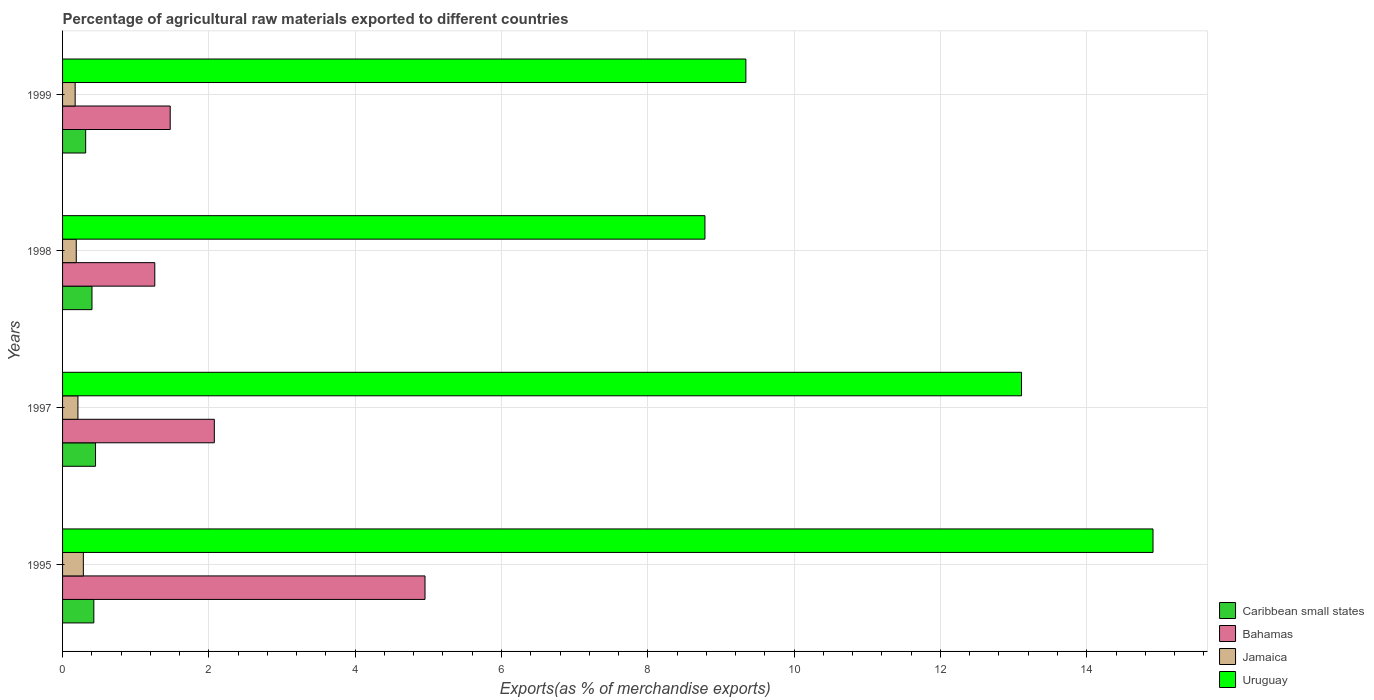How many groups of bars are there?
Give a very brief answer. 4. What is the label of the 2nd group of bars from the top?
Provide a succinct answer. 1998. What is the percentage of exports to different countries in Bahamas in 1999?
Your answer should be compact. 1.47. Across all years, what is the maximum percentage of exports to different countries in Jamaica?
Your answer should be very brief. 0.28. Across all years, what is the minimum percentage of exports to different countries in Uruguay?
Give a very brief answer. 8.78. In which year was the percentage of exports to different countries in Bahamas minimum?
Your response must be concise. 1998. What is the total percentage of exports to different countries in Bahamas in the graph?
Offer a terse response. 9.76. What is the difference between the percentage of exports to different countries in Jamaica in 1995 and that in 1997?
Your answer should be compact. 0.07. What is the difference between the percentage of exports to different countries in Caribbean small states in 1997 and the percentage of exports to different countries in Bahamas in 1998?
Your answer should be compact. -0.81. What is the average percentage of exports to different countries in Bahamas per year?
Offer a terse response. 2.44. In the year 1997, what is the difference between the percentage of exports to different countries in Uruguay and percentage of exports to different countries in Caribbean small states?
Your response must be concise. 12.66. In how many years, is the percentage of exports to different countries in Jamaica greater than 11.2 %?
Give a very brief answer. 0. What is the ratio of the percentage of exports to different countries in Bahamas in 1995 to that in 1998?
Ensure brevity in your answer.  3.93. Is the percentage of exports to different countries in Uruguay in 1997 less than that in 1998?
Give a very brief answer. No. What is the difference between the highest and the second highest percentage of exports to different countries in Caribbean small states?
Provide a short and direct response. 0.02. What is the difference between the highest and the lowest percentage of exports to different countries in Jamaica?
Provide a short and direct response. 0.11. Is it the case that in every year, the sum of the percentage of exports to different countries in Caribbean small states and percentage of exports to different countries in Uruguay is greater than the sum of percentage of exports to different countries in Jamaica and percentage of exports to different countries in Bahamas?
Give a very brief answer. Yes. What does the 3rd bar from the top in 1998 represents?
Your answer should be compact. Bahamas. What does the 3rd bar from the bottom in 1998 represents?
Offer a very short reply. Jamaica. Is it the case that in every year, the sum of the percentage of exports to different countries in Jamaica and percentage of exports to different countries in Uruguay is greater than the percentage of exports to different countries in Bahamas?
Provide a succinct answer. Yes. Are all the bars in the graph horizontal?
Your answer should be very brief. Yes. Are the values on the major ticks of X-axis written in scientific E-notation?
Provide a succinct answer. No. Does the graph contain any zero values?
Provide a succinct answer. No. Does the graph contain grids?
Keep it short and to the point. Yes. Where does the legend appear in the graph?
Ensure brevity in your answer.  Bottom right. How many legend labels are there?
Provide a succinct answer. 4. What is the title of the graph?
Give a very brief answer. Percentage of agricultural raw materials exported to different countries. What is the label or title of the X-axis?
Offer a terse response. Exports(as % of merchandise exports). What is the Exports(as % of merchandise exports) in Caribbean small states in 1995?
Offer a terse response. 0.43. What is the Exports(as % of merchandise exports) in Bahamas in 1995?
Your answer should be compact. 4.95. What is the Exports(as % of merchandise exports) of Jamaica in 1995?
Your answer should be compact. 0.28. What is the Exports(as % of merchandise exports) of Uruguay in 1995?
Your answer should be compact. 14.91. What is the Exports(as % of merchandise exports) in Caribbean small states in 1997?
Make the answer very short. 0.45. What is the Exports(as % of merchandise exports) of Bahamas in 1997?
Make the answer very short. 2.07. What is the Exports(as % of merchandise exports) of Jamaica in 1997?
Your answer should be compact. 0.21. What is the Exports(as % of merchandise exports) of Uruguay in 1997?
Provide a succinct answer. 13.11. What is the Exports(as % of merchandise exports) in Caribbean small states in 1998?
Your answer should be very brief. 0.4. What is the Exports(as % of merchandise exports) of Bahamas in 1998?
Your answer should be very brief. 1.26. What is the Exports(as % of merchandise exports) in Jamaica in 1998?
Offer a very short reply. 0.19. What is the Exports(as % of merchandise exports) of Uruguay in 1998?
Offer a very short reply. 8.78. What is the Exports(as % of merchandise exports) in Caribbean small states in 1999?
Provide a succinct answer. 0.32. What is the Exports(as % of merchandise exports) of Bahamas in 1999?
Offer a terse response. 1.47. What is the Exports(as % of merchandise exports) of Jamaica in 1999?
Ensure brevity in your answer.  0.17. What is the Exports(as % of merchandise exports) in Uruguay in 1999?
Your answer should be very brief. 9.34. Across all years, what is the maximum Exports(as % of merchandise exports) of Caribbean small states?
Ensure brevity in your answer.  0.45. Across all years, what is the maximum Exports(as % of merchandise exports) in Bahamas?
Make the answer very short. 4.95. Across all years, what is the maximum Exports(as % of merchandise exports) of Jamaica?
Make the answer very short. 0.28. Across all years, what is the maximum Exports(as % of merchandise exports) in Uruguay?
Make the answer very short. 14.91. Across all years, what is the minimum Exports(as % of merchandise exports) in Caribbean small states?
Provide a short and direct response. 0.32. Across all years, what is the minimum Exports(as % of merchandise exports) in Bahamas?
Offer a very short reply. 1.26. Across all years, what is the minimum Exports(as % of merchandise exports) in Jamaica?
Provide a short and direct response. 0.17. Across all years, what is the minimum Exports(as % of merchandise exports) in Uruguay?
Your response must be concise. 8.78. What is the total Exports(as % of merchandise exports) in Caribbean small states in the graph?
Give a very brief answer. 1.6. What is the total Exports(as % of merchandise exports) in Bahamas in the graph?
Your answer should be compact. 9.76. What is the total Exports(as % of merchandise exports) of Jamaica in the graph?
Provide a short and direct response. 0.85. What is the total Exports(as % of merchandise exports) in Uruguay in the graph?
Provide a succinct answer. 46.13. What is the difference between the Exports(as % of merchandise exports) of Caribbean small states in 1995 and that in 1997?
Your answer should be compact. -0.02. What is the difference between the Exports(as % of merchandise exports) in Bahamas in 1995 and that in 1997?
Keep it short and to the point. 2.88. What is the difference between the Exports(as % of merchandise exports) in Jamaica in 1995 and that in 1997?
Give a very brief answer. 0.07. What is the difference between the Exports(as % of merchandise exports) in Uruguay in 1995 and that in 1997?
Ensure brevity in your answer.  1.8. What is the difference between the Exports(as % of merchandise exports) in Caribbean small states in 1995 and that in 1998?
Ensure brevity in your answer.  0.03. What is the difference between the Exports(as % of merchandise exports) of Bahamas in 1995 and that in 1998?
Offer a very short reply. 3.69. What is the difference between the Exports(as % of merchandise exports) of Jamaica in 1995 and that in 1998?
Provide a succinct answer. 0.1. What is the difference between the Exports(as % of merchandise exports) of Uruguay in 1995 and that in 1998?
Offer a terse response. 6.12. What is the difference between the Exports(as % of merchandise exports) of Caribbean small states in 1995 and that in 1999?
Give a very brief answer. 0.11. What is the difference between the Exports(as % of merchandise exports) of Bahamas in 1995 and that in 1999?
Keep it short and to the point. 3.48. What is the difference between the Exports(as % of merchandise exports) of Jamaica in 1995 and that in 1999?
Give a very brief answer. 0.11. What is the difference between the Exports(as % of merchandise exports) of Uruguay in 1995 and that in 1999?
Your answer should be compact. 5.57. What is the difference between the Exports(as % of merchandise exports) in Caribbean small states in 1997 and that in 1998?
Ensure brevity in your answer.  0.05. What is the difference between the Exports(as % of merchandise exports) in Bahamas in 1997 and that in 1998?
Ensure brevity in your answer.  0.81. What is the difference between the Exports(as % of merchandise exports) in Jamaica in 1997 and that in 1998?
Your answer should be compact. 0.02. What is the difference between the Exports(as % of merchandise exports) of Uruguay in 1997 and that in 1998?
Provide a short and direct response. 4.33. What is the difference between the Exports(as % of merchandise exports) in Caribbean small states in 1997 and that in 1999?
Offer a terse response. 0.13. What is the difference between the Exports(as % of merchandise exports) of Bahamas in 1997 and that in 1999?
Offer a terse response. 0.6. What is the difference between the Exports(as % of merchandise exports) of Jamaica in 1997 and that in 1999?
Your answer should be very brief. 0.04. What is the difference between the Exports(as % of merchandise exports) of Uruguay in 1997 and that in 1999?
Your response must be concise. 3.77. What is the difference between the Exports(as % of merchandise exports) in Caribbean small states in 1998 and that in 1999?
Keep it short and to the point. 0.09. What is the difference between the Exports(as % of merchandise exports) of Bahamas in 1998 and that in 1999?
Your answer should be very brief. -0.21. What is the difference between the Exports(as % of merchandise exports) in Jamaica in 1998 and that in 1999?
Offer a terse response. 0.02. What is the difference between the Exports(as % of merchandise exports) of Uruguay in 1998 and that in 1999?
Make the answer very short. -0.56. What is the difference between the Exports(as % of merchandise exports) of Caribbean small states in 1995 and the Exports(as % of merchandise exports) of Bahamas in 1997?
Give a very brief answer. -1.65. What is the difference between the Exports(as % of merchandise exports) in Caribbean small states in 1995 and the Exports(as % of merchandise exports) in Jamaica in 1997?
Ensure brevity in your answer.  0.22. What is the difference between the Exports(as % of merchandise exports) in Caribbean small states in 1995 and the Exports(as % of merchandise exports) in Uruguay in 1997?
Your response must be concise. -12.68. What is the difference between the Exports(as % of merchandise exports) of Bahamas in 1995 and the Exports(as % of merchandise exports) of Jamaica in 1997?
Your response must be concise. 4.74. What is the difference between the Exports(as % of merchandise exports) in Bahamas in 1995 and the Exports(as % of merchandise exports) in Uruguay in 1997?
Your response must be concise. -8.15. What is the difference between the Exports(as % of merchandise exports) in Jamaica in 1995 and the Exports(as % of merchandise exports) in Uruguay in 1997?
Your response must be concise. -12.82. What is the difference between the Exports(as % of merchandise exports) in Caribbean small states in 1995 and the Exports(as % of merchandise exports) in Bahamas in 1998?
Offer a very short reply. -0.83. What is the difference between the Exports(as % of merchandise exports) in Caribbean small states in 1995 and the Exports(as % of merchandise exports) in Jamaica in 1998?
Offer a terse response. 0.24. What is the difference between the Exports(as % of merchandise exports) of Caribbean small states in 1995 and the Exports(as % of merchandise exports) of Uruguay in 1998?
Make the answer very short. -8.35. What is the difference between the Exports(as % of merchandise exports) in Bahamas in 1995 and the Exports(as % of merchandise exports) in Jamaica in 1998?
Offer a terse response. 4.77. What is the difference between the Exports(as % of merchandise exports) in Bahamas in 1995 and the Exports(as % of merchandise exports) in Uruguay in 1998?
Offer a terse response. -3.83. What is the difference between the Exports(as % of merchandise exports) of Jamaica in 1995 and the Exports(as % of merchandise exports) of Uruguay in 1998?
Ensure brevity in your answer.  -8.5. What is the difference between the Exports(as % of merchandise exports) in Caribbean small states in 1995 and the Exports(as % of merchandise exports) in Bahamas in 1999?
Keep it short and to the point. -1.04. What is the difference between the Exports(as % of merchandise exports) of Caribbean small states in 1995 and the Exports(as % of merchandise exports) of Jamaica in 1999?
Ensure brevity in your answer.  0.26. What is the difference between the Exports(as % of merchandise exports) in Caribbean small states in 1995 and the Exports(as % of merchandise exports) in Uruguay in 1999?
Provide a succinct answer. -8.91. What is the difference between the Exports(as % of merchandise exports) in Bahamas in 1995 and the Exports(as % of merchandise exports) in Jamaica in 1999?
Make the answer very short. 4.78. What is the difference between the Exports(as % of merchandise exports) of Bahamas in 1995 and the Exports(as % of merchandise exports) of Uruguay in 1999?
Provide a succinct answer. -4.39. What is the difference between the Exports(as % of merchandise exports) in Jamaica in 1995 and the Exports(as % of merchandise exports) in Uruguay in 1999?
Ensure brevity in your answer.  -9.06. What is the difference between the Exports(as % of merchandise exports) of Caribbean small states in 1997 and the Exports(as % of merchandise exports) of Bahamas in 1998?
Offer a very short reply. -0.81. What is the difference between the Exports(as % of merchandise exports) in Caribbean small states in 1997 and the Exports(as % of merchandise exports) in Jamaica in 1998?
Your answer should be very brief. 0.26. What is the difference between the Exports(as % of merchandise exports) of Caribbean small states in 1997 and the Exports(as % of merchandise exports) of Uruguay in 1998?
Your answer should be very brief. -8.33. What is the difference between the Exports(as % of merchandise exports) in Bahamas in 1997 and the Exports(as % of merchandise exports) in Jamaica in 1998?
Ensure brevity in your answer.  1.89. What is the difference between the Exports(as % of merchandise exports) of Bahamas in 1997 and the Exports(as % of merchandise exports) of Uruguay in 1998?
Offer a very short reply. -6.71. What is the difference between the Exports(as % of merchandise exports) in Jamaica in 1997 and the Exports(as % of merchandise exports) in Uruguay in 1998?
Offer a terse response. -8.57. What is the difference between the Exports(as % of merchandise exports) of Caribbean small states in 1997 and the Exports(as % of merchandise exports) of Bahamas in 1999?
Make the answer very short. -1.02. What is the difference between the Exports(as % of merchandise exports) in Caribbean small states in 1997 and the Exports(as % of merchandise exports) in Jamaica in 1999?
Offer a very short reply. 0.28. What is the difference between the Exports(as % of merchandise exports) in Caribbean small states in 1997 and the Exports(as % of merchandise exports) in Uruguay in 1999?
Provide a short and direct response. -8.89. What is the difference between the Exports(as % of merchandise exports) in Bahamas in 1997 and the Exports(as % of merchandise exports) in Jamaica in 1999?
Make the answer very short. 1.9. What is the difference between the Exports(as % of merchandise exports) in Bahamas in 1997 and the Exports(as % of merchandise exports) in Uruguay in 1999?
Offer a terse response. -7.27. What is the difference between the Exports(as % of merchandise exports) in Jamaica in 1997 and the Exports(as % of merchandise exports) in Uruguay in 1999?
Keep it short and to the point. -9.13. What is the difference between the Exports(as % of merchandise exports) of Caribbean small states in 1998 and the Exports(as % of merchandise exports) of Bahamas in 1999?
Offer a very short reply. -1.07. What is the difference between the Exports(as % of merchandise exports) in Caribbean small states in 1998 and the Exports(as % of merchandise exports) in Jamaica in 1999?
Your answer should be compact. 0.23. What is the difference between the Exports(as % of merchandise exports) of Caribbean small states in 1998 and the Exports(as % of merchandise exports) of Uruguay in 1999?
Your response must be concise. -8.94. What is the difference between the Exports(as % of merchandise exports) of Bahamas in 1998 and the Exports(as % of merchandise exports) of Jamaica in 1999?
Your answer should be very brief. 1.09. What is the difference between the Exports(as % of merchandise exports) in Bahamas in 1998 and the Exports(as % of merchandise exports) in Uruguay in 1999?
Offer a very short reply. -8.08. What is the difference between the Exports(as % of merchandise exports) of Jamaica in 1998 and the Exports(as % of merchandise exports) of Uruguay in 1999?
Make the answer very short. -9.15. What is the average Exports(as % of merchandise exports) in Caribbean small states per year?
Keep it short and to the point. 0.4. What is the average Exports(as % of merchandise exports) of Bahamas per year?
Keep it short and to the point. 2.44. What is the average Exports(as % of merchandise exports) of Jamaica per year?
Offer a terse response. 0.21. What is the average Exports(as % of merchandise exports) in Uruguay per year?
Offer a very short reply. 11.53. In the year 1995, what is the difference between the Exports(as % of merchandise exports) of Caribbean small states and Exports(as % of merchandise exports) of Bahamas?
Make the answer very short. -4.53. In the year 1995, what is the difference between the Exports(as % of merchandise exports) of Caribbean small states and Exports(as % of merchandise exports) of Jamaica?
Keep it short and to the point. 0.14. In the year 1995, what is the difference between the Exports(as % of merchandise exports) in Caribbean small states and Exports(as % of merchandise exports) in Uruguay?
Offer a very short reply. -14.48. In the year 1995, what is the difference between the Exports(as % of merchandise exports) in Bahamas and Exports(as % of merchandise exports) in Jamaica?
Your answer should be very brief. 4.67. In the year 1995, what is the difference between the Exports(as % of merchandise exports) of Bahamas and Exports(as % of merchandise exports) of Uruguay?
Keep it short and to the point. -9.95. In the year 1995, what is the difference between the Exports(as % of merchandise exports) of Jamaica and Exports(as % of merchandise exports) of Uruguay?
Keep it short and to the point. -14.62. In the year 1997, what is the difference between the Exports(as % of merchandise exports) of Caribbean small states and Exports(as % of merchandise exports) of Bahamas?
Your response must be concise. -1.62. In the year 1997, what is the difference between the Exports(as % of merchandise exports) of Caribbean small states and Exports(as % of merchandise exports) of Jamaica?
Make the answer very short. 0.24. In the year 1997, what is the difference between the Exports(as % of merchandise exports) of Caribbean small states and Exports(as % of merchandise exports) of Uruguay?
Provide a succinct answer. -12.66. In the year 1997, what is the difference between the Exports(as % of merchandise exports) in Bahamas and Exports(as % of merchandise exports) in Jamaica?
Your answer should be compact. 1.86. In the year 1997, what is the difference between the Exports(as % of merchandise exports) of Bahamas and Exports(as % of merchandise exports) of Uruguay?
Offer a very short reply. -11.03. In the year 1997, what is the difference between the Exports(as % of merchandise exports) of Jamaica and Exports(as % of merchandise exports) of Uruguay?
Give a very brief answer. -12.9. In the year 1998, what is the difference between the Exports(as % of merchandise exports) of Caribbean small states and Exports(as % of merchandise exports) of Bahamas?
Your response must be concise. -0.86. In the year 1998, what is the difference between the Exports(as % of merchandise exports) of Caribbean small states and Exports(as % of merchandise exports) of Jamaica?
Provide a short and direct response. 0.21. In the year 1998, what is the difference between the Exports(as % of merchandise exports) of Caribbean small states and Exports(as % of merchandise exports) of Uruguay?
Ensure brevity in your answer.  -8.38. In the year 1998, what is the difference between the Exports(as % of merchandise exports) in Bahamas and Exports(as % of merchandise exports) in Jamaica?
Give a very brief answer. 1.07. In the year 1998, what is the difference between the Exports(as % of merchandise exports) in Bahamas and Exports(as % of merchandise exports) in Uruguay?
Give a very brief answer. -7.52. In the year 1998, what is the difference between the Exports(as % of merchandise exports) of Jamaica and Exports(as % of merchandise exports) of Uruguay?
Give a very brief answer. -8.59. In the year 1999, what is the difference between the Exports(as % of merchandise exports) in Caribbean small states and Exports(as % of merchandise exports) in Bahamas?
Your response must be concise. -1.16. In the year 1999, what is the difference between the Exports(as % of merchandise exports) of Caribbean small states and Exports(as % of merchandise exports) of Jamaica?
Provide a succinct answer. 0.14. In the year 1999, what is the difference between the Exports(as % of merchandise exports) of Caribbean small states and Exports(as % of merchandise exports) of Uruguay?
Provide a succinct answer. -9.02. In the year 1999, what is the difference between the Exports(as % of merchandise exports) of Bahamas and Exports(as % of merchandise exports) of Jamaica?
Give a very brief answer. 1.3. In the year 1999, what is the difference between the Exports(as % of merchandise exports) of Bahamas and Exports(as % of merchandise exports) of Uruguay?
Give a very brief answer. -7.87. In the year 1999, what is the difference between the Exports(as % of merchandise exports) in Jamaica and Exports(as % of merchandise exports) in Uruguay?
Provide a short and direct response. -9.17. What is the ratio of the Exports(as % of merchandise exports) of Caribbean small states in 1995 to that in 1997?
Your response must be concise. 0.95. What is the ratio of the Exports(as % of merchandise exports) of Bahamas in 1995 to that in 1997?
Your answer should be very brief. 2.39. What is the ratio of the Exports(as % of merchandise exports) in Jamaica in 1995 to that in 1997?
Offer a terse response. 1.35. What is the ratio of the Exports(as % of merchandise exports) in Uruguay in 1995 to that in 1997?
Provide a short and direct response. 1.14. What is the ratio of the Exports(as % of merchandise exports) in Caribbean small states in 1995 to that in 1998?
Your response must be concise. 1.06. What is the ratio of the Exports(as % of merchandise exports) in Bahamas in 1995 to that in 1998?
Offer a terse response. 3.93. What is the ratio of the Exports(as % of merchandise exports) of Jamaica in 1995 to that in 1998?
Keep it short and to the point. 1.52. What is the ratio of the Exports(as % of merchandise exports) in Uruguay in 1995 to that in 1998?
Keep it short and to the point. 1.7. What is the ratio of the Exports(as % of merchandise exports) in Caribbean small states in 1995 to that in 1999?
Provide a short and direct response. 1.35. What is the ratio of the Exports(as % of merchandise exports) of Bahamas in 1995 to that in 1999?
Your answer should be compact. 3.37. What is the ratio of the Exports(as % of merchandise exports) of Jamaica in 1995 to that in 1999?
Give a very brief answer. 1.65. What is the ratio of the Exports(as % of merchandise exports) of Uruguay in 1995 to that in 1999?
Offer a terse response. 1.6. What is the ratio of the Exports(as % of merchandise exports) in Caribbean small states in 1997 to that in 1998?
Offer a very short reply. 1.12. What is the ratio of the Exports(as % of merchandise exports) of Bahamas in 1997 to that in 1998?
Provide a succinct answer. 1.65. What is the ratio of the Exports(as % of merchandise exports) of Jamaica in 1997 to that in 1998?
Your answer should be very brief. 1.12. What is the ratio of the Exports(as % of merchandise exports) in Uruguay in 1997 to that in 1998?
Provide a succinct answer. 1.49. What is the ratio of the Exports(as % of merchandise exports) in Caribbean small states in 1997 to that in 1999?
Ensure brevity in your answer.  1.43. What is the ratio of the Exports(as % of merchandise exports) of Bahamas in 1997 to that in 1999?
Keep it short and to the point. 1.41. What is the ratio of the Exports(as % of merchandise exports) of Jamaica in 1997 to that in 1999?
Give a very brief answer. 1.22. What is the ratio of the Exports(as % of merchandise exports) in Uruguay in 1997 to that in 1999?
Give a very brief answer. 1.4. What is the ratio of the Exports(as % of merchandise exports) in Caribbean small states in 1998 to that in 1999?
Keep it short and to the point. 1.27. What is the ratio of the Exports(as % of merchandise exports) of Bahamas in 1998 to that in 1999?
Provide a short and direct response. 0.86. What is the ratio of the Exports(as % of merchandise exports) of Jamaica in 1998 to that in 1999?
Keep it short and to the point. 1.09. What is the ratio of the Exports(as % of merchandise exports) in Uruguay in 1998 to that in 1999?
Keep it short and to the point. 0.94. What is the difference between the highest and the second highest Exports(as % of merchandise exports) in Caribbean small states?
Make the answer very short. 0.02. What is the difference between the highest and the second highest Exports(as % of merchandise exports) in Bahamas?
Keep it short and to the point. 2.88. What is the difference between the highest and the second highest Exports(as % of merchandise exports) in Jamaica?
Ensure brevity in your answer.  0.07. What is the difference between the highest and the second highest Exports(as % of merchandise exports) in Uruguay?
Ensure brevity in your answer.  1.8. What is the difference between the highest and the lowest Exports(as % of merchandise exports) in Caribbean small states?
Offer a very short reply. 0.13. What is the difference between the highest and the lowest Exports(as % of merchandise exports) of Bahamas?
Give a very brief answer. 3.69. What is the difference between the highest and the lowest Exports(as % of merchandise exports) of Jamaica?
Give a very brief answer. 0.11. What is the difference between the highest and the lowest Exports(as % of merchandise exports) of Uruguay?
Your answer should be very brief. 6.12. 